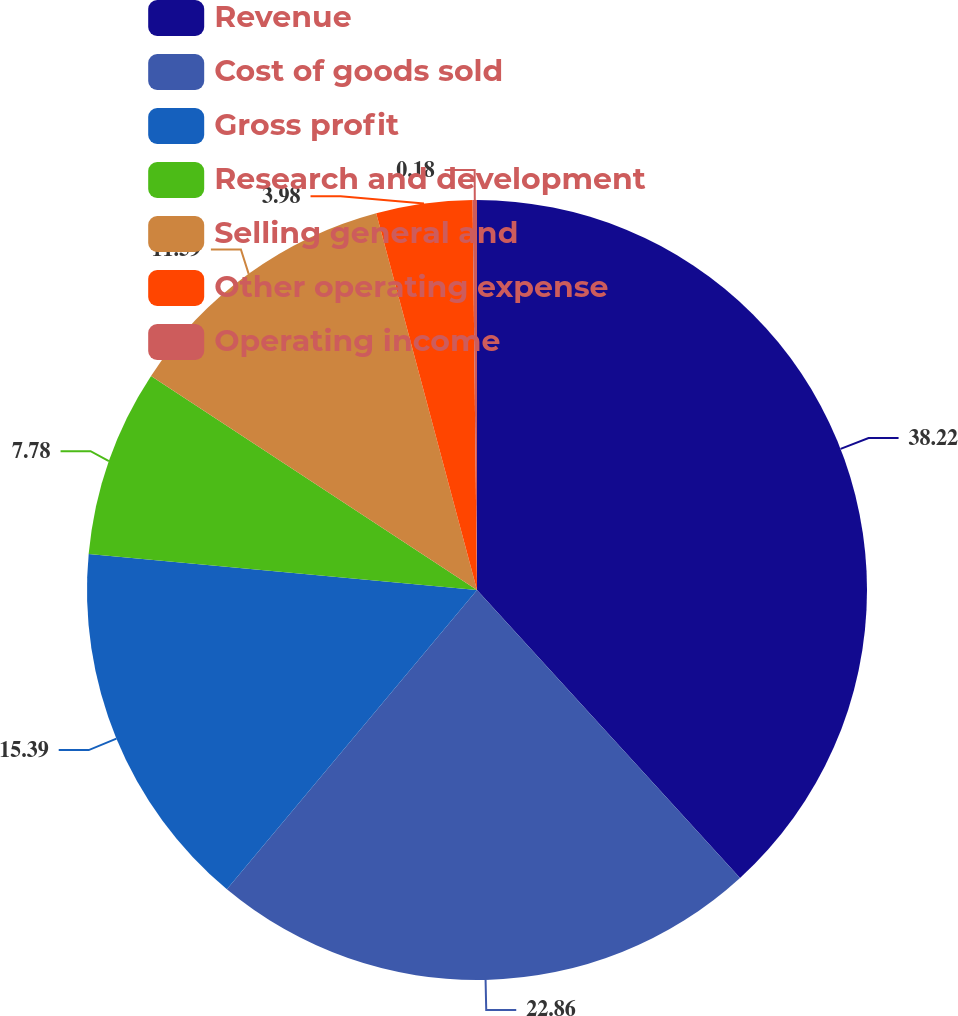Convert chart to OTSL. <chart><loc_0><loc_0><loc_500><loc_500><pie_chart><fcel>Revenue<fcel>Cost of goods sold<fcel>Gross profit<fcel>Research and development<fcel>Selling general and<fcel>Other operating expense<fcel>Operating income<nl><fcel>38.22%<fcel>22.86%<fcel>15.39%<fcel>7.78%<fcel>11.59%<fcel>3.98%<fcel>0.18%<nl></chart> 